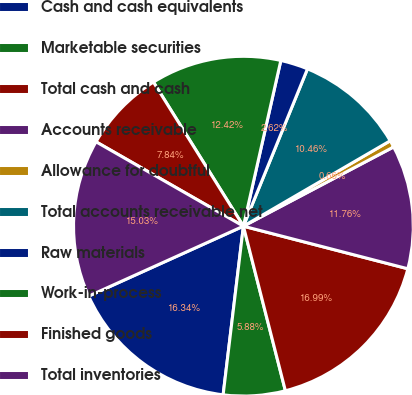<chart> <loc_0><loc_0><loc_500><loc_500><pie_chart><fcel>Cash and cash equivalents<fcel>Marketable securities<fcel>Total cash and cash<fcel>Accounts receivable<fcel>Allowance for doubtful<fcel>Total accounts receivable net<fcel>Raw materials<fcel>Work-in-process<fcel>Finished goods<fcel>Total inventories<nl><fcel>16.34%<fcel>5.88%<fcel>16.99%<fcel>11.76%<fcel>0.66%<fcel>10.46%<fcel>2.62%<fcel>12.42%<fcel>7.84%<fcel>15.03%<nl></chart> 